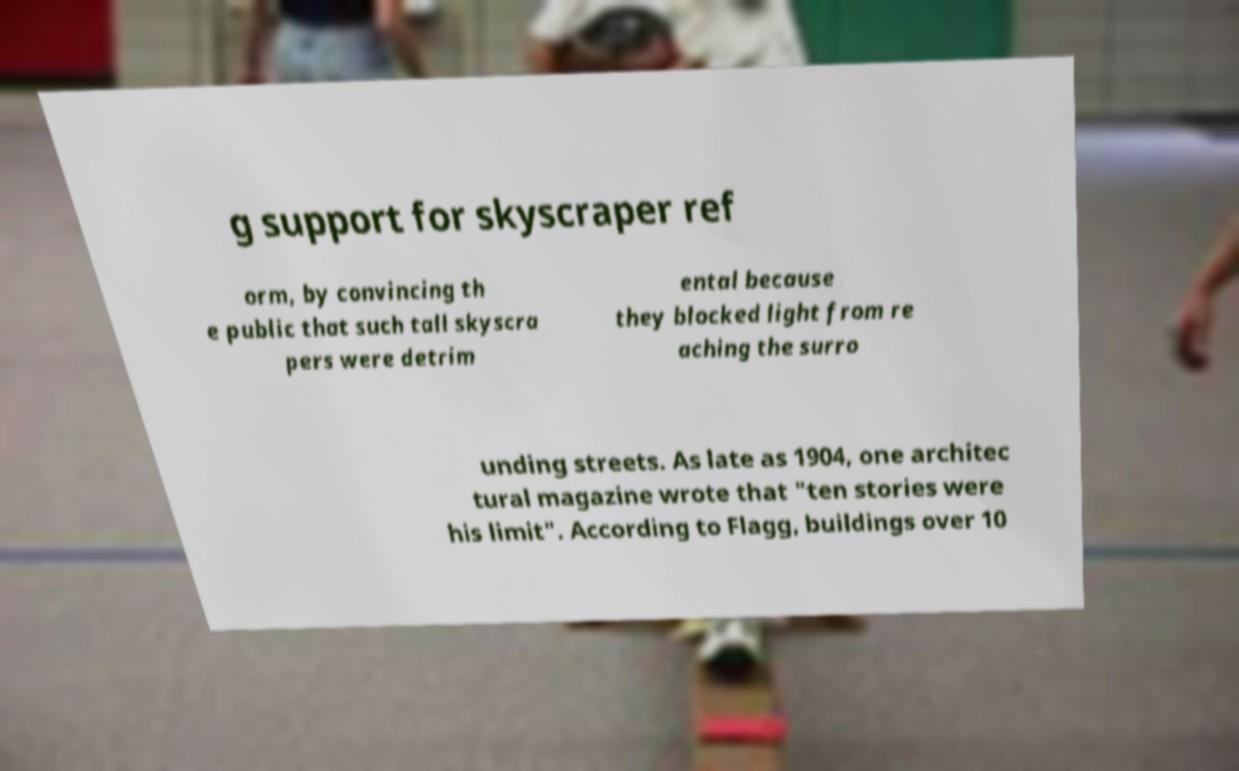Please identify and transcribe the text found in this image. g support for skyscraper ref orm, by convincing th e public that such tall skyscra pers were detrim ental because they blocked light from re aching the surro unding streets. As late as 1904, one architec tural magazine wrote that "ten stories were his limit". According to Flagg, buildings over 10 